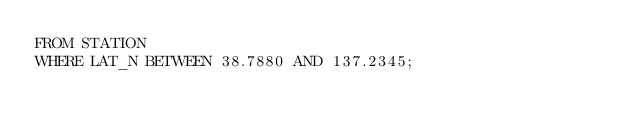Convert code to text. <code><loc_0><loc_0><loc_500><loc_500><_SQL_>FROM STATION
WHERE LAT_N BETWEEN 38.7880 AND 137.2345;</code> 